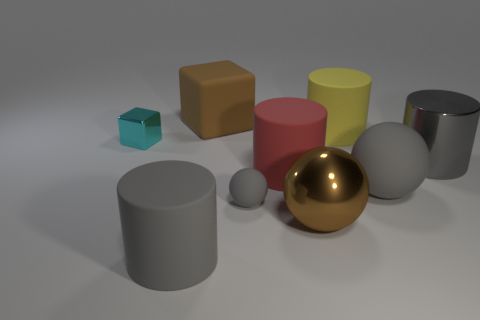There is a big gray rubber thing that is right of the big red object that is in front of the small block; is there a sphere to the right of it?
Keep it short and to the point. No. Is there anything else that has the same material as the large yellow thing?
Offer a terse response. Yes. The large gray object that is made of the same material as the cyan thing is what shape?
Your answer should be compact. Cylinder. Are there fewer metallic things that are to the left of the large gray ball than big brown things that are behind the small rubber object?
Your answer should be very brief. No. What number of tiny things are either blocks or brown matte cubes?
Give a very brief answer. 1. There is a big brown thing in front of the cyan object; does it have the same shape as the large brown thing left of the small gray object?
Make the answer very short. No. What is the size of the gray metallic thing that is behind the big gray rubber thing that is to the right of the gray cylinder in front of the small gray sphere?
Your response must be concise. Large. How big is the gray cylinder that is to the left of the big shiny cylinder?
Give a very brief answer. Large. There is a block that is in front of the large matte cube; what material is it?
Offer a terse response. Metal. How many red things are tiny things or cylinders?
Provide a succinct answer. 1. 